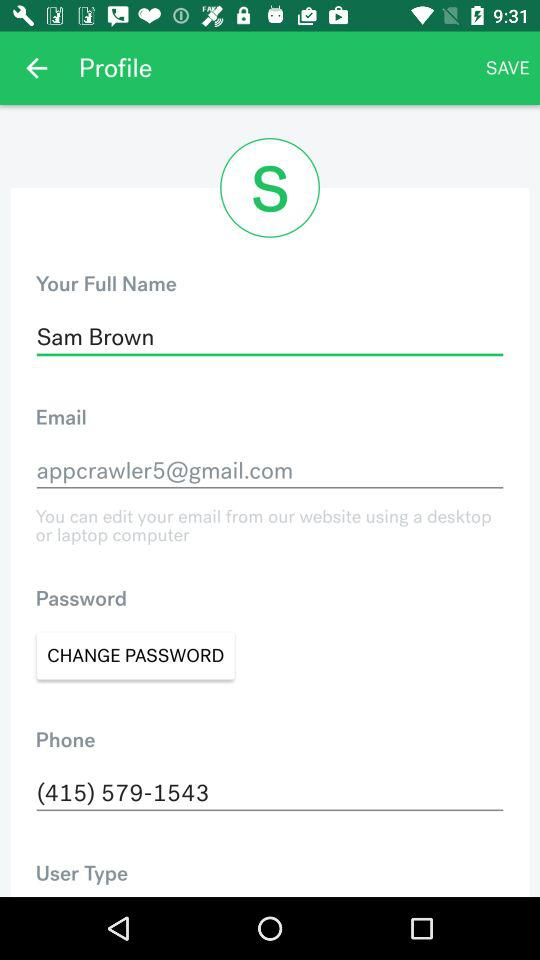How many text inputs contain an email address?
Answer the question using a single word or phrase. 1 